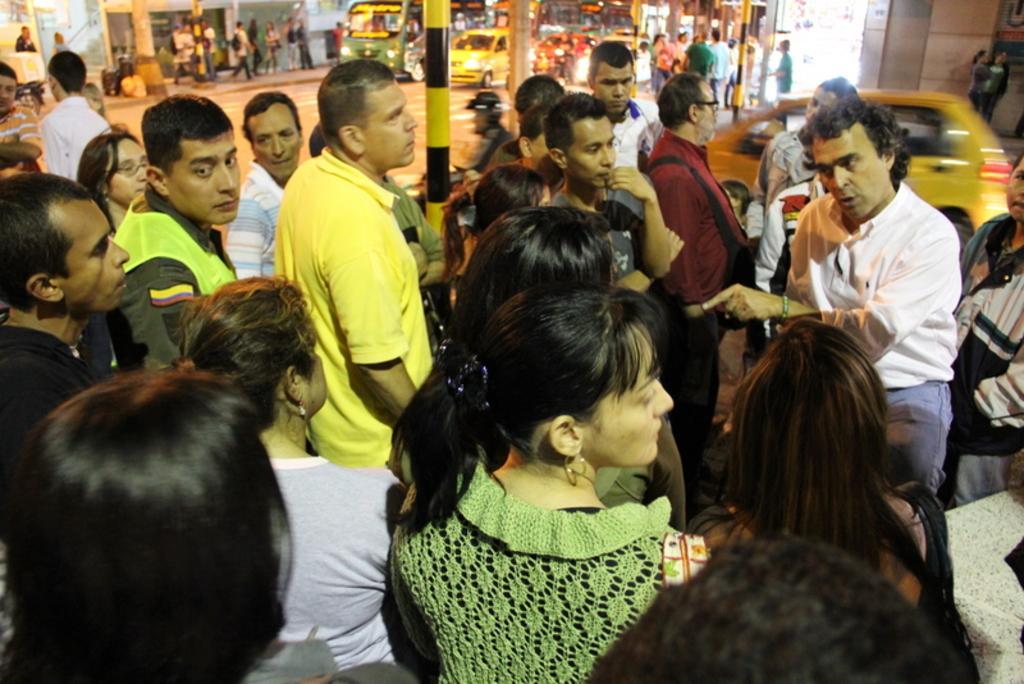How would you summarize this image in a sentence or two? In this image, in the front there are group of persons standing. In the center there is a pole and there is a car which is yellow in colour moving. In the background there are persons walking, standing and there are buildings and vehicles. 